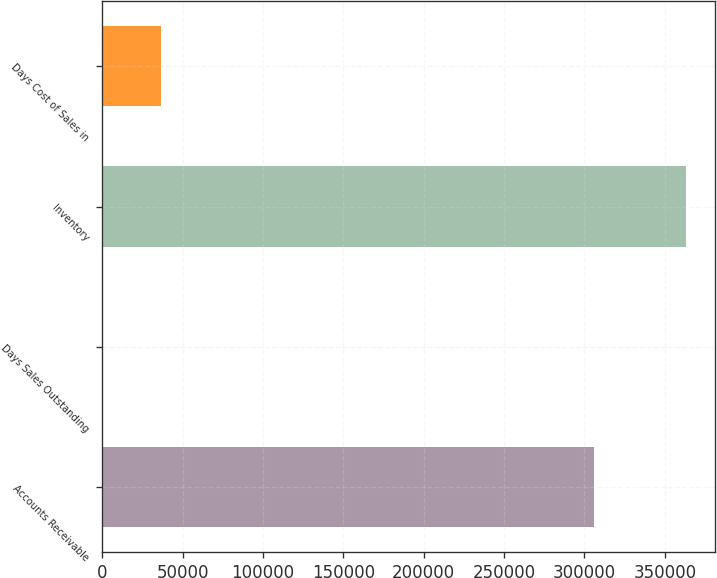Convert chart. <chart><loc_0><loc_0><loc_500><loc_500><bar_chart><fcel>Accounts Receivable<fcel>Days Sales Outstanding<fcel>Inventory<fcel>Days Cost of Sales in<nl><fcel>305761<fcel>46<fcel>362945<fcel>36335.9<nl></chart> 